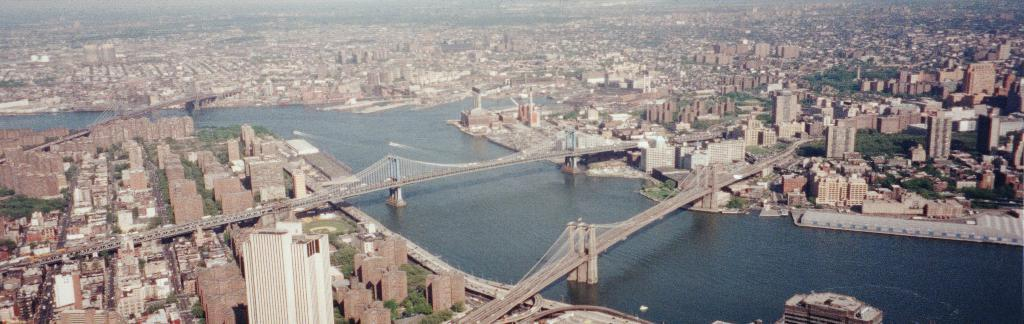What type of structures can be seen in the image? There are buildings in the image. What type of natural elements can be seen in the image? There are trees in the image. What type of man-made structures can be seen in the image? There are bridges in the image. What type of natural feature is visible in the image? There is water visible in the image. What is the value of the poisonous thought in the image? There is no mention of poison or thought in the image, so it is not possible to determine a value. 